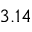Convert formula to latex. <formula><loc_0><loc_0><loc_500><loc_500>3 . 1 4</formula> 